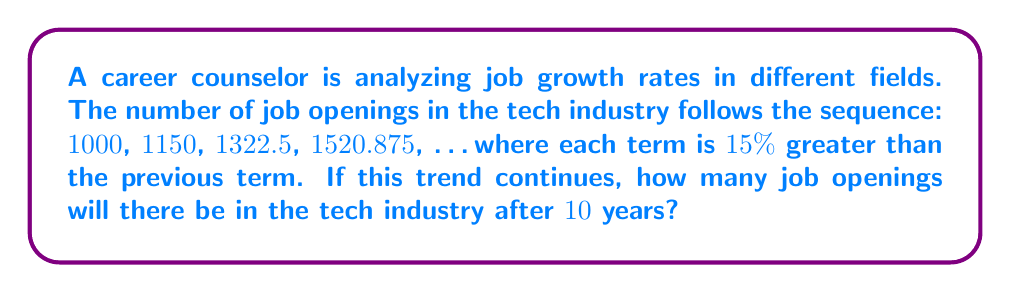Solve this math problem. To solve this problem, we need to follow these steps:

1) Identify the growth rate:
   The sequence increases by 15% each term, so the growth rate is 1.15 or 115%.

2) Determine the number of terms:
   We need to find the 10th term in the sequence, as each term represents a year.

3) Use the exponential growth formula:
   $$A = P(1 + r)^n$$
   Where:
   $A$ = Final amount
   $P$ = Initial amount (1000)
   $r$ = Growth rate (0.15)
   $n$ = Number of periods (10)

4) Plug in the values:
   $$A = 1000(1 + 0.15)^{10}$$

5) Calculate:
   $$A = 1000(1.15)^{10}$$
   $$A = 1000(4.0456)$$
   $$A = 4045.60$$

6) Round to the nearest whole number:
   4046 job openings
Answer: 4046 